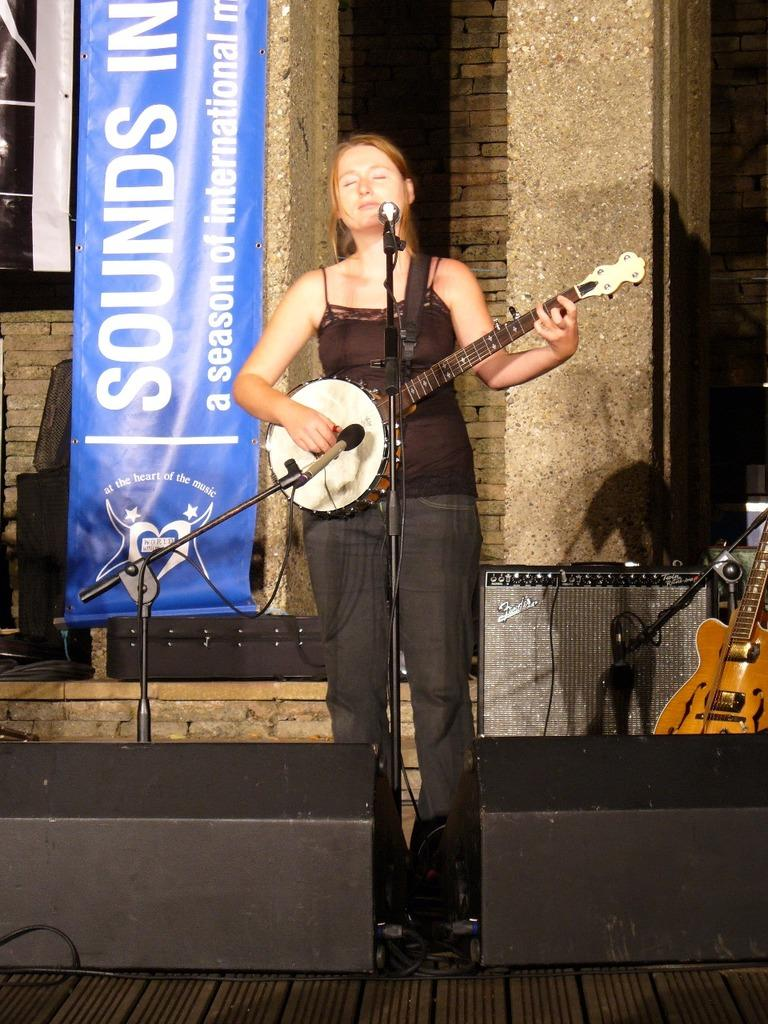Who is the main subject in the image? There is a woman in the image. What is the woman doing in the image? The woman is standing and playing a guitar. What object is present in the image that is typically used for amplifying sound? There is a microphone in the image. What type of berry can be seen in the woman's hand in the image? There is no berry present in the image; the woman is holding a guitar. How many crates are visible in the image? There are no crates present in the image. 